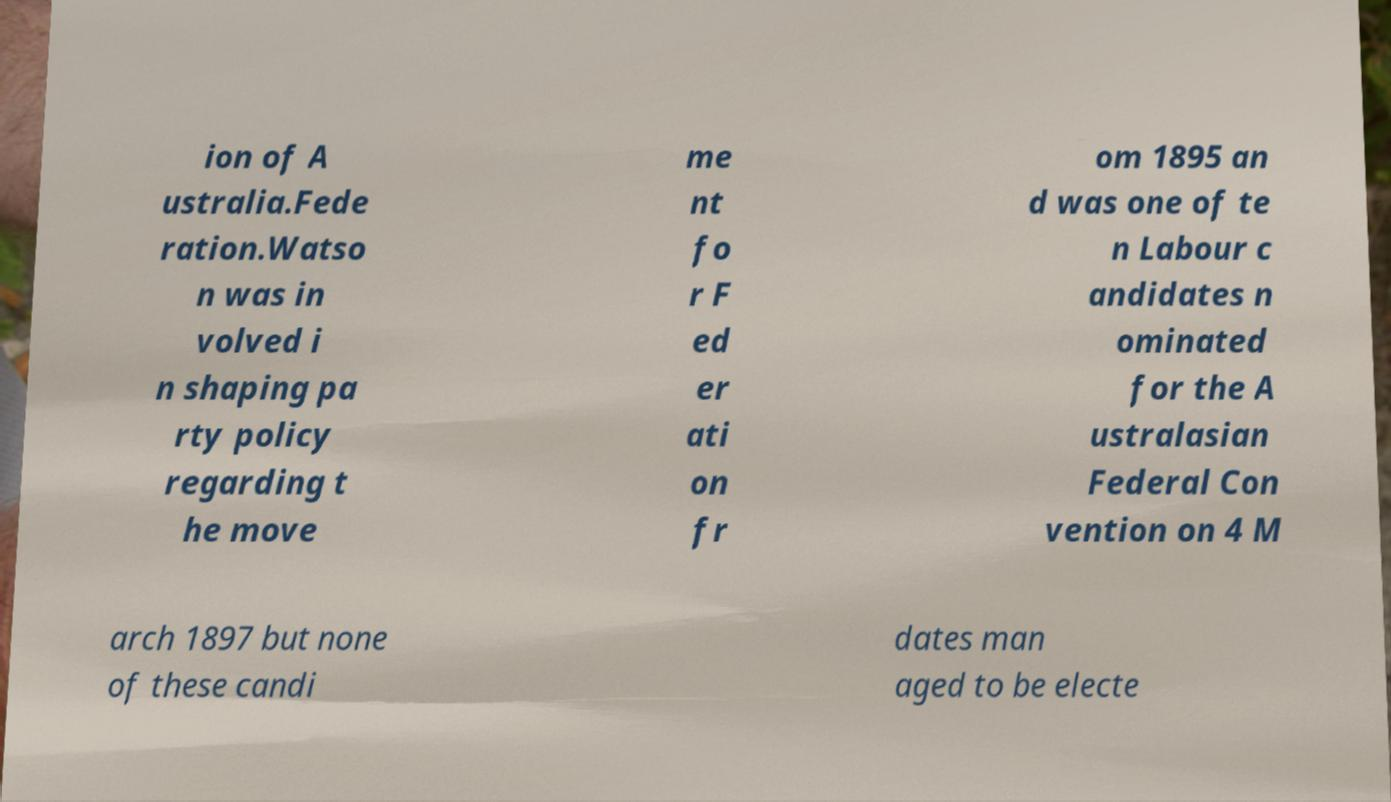Please read and relay the text visible in this image. What does it say? ion of A ustralia.Fede ration.Watso n was in volved i n shaping pa rty policy regarding t he move me nt fo r F ed er ati on fr om 1895 an d was one of te n Labour c andidates n ominated for the A ustralasian Federal Con vention on 4 M arch 1897 but none of these candi dates man aged to be electe 